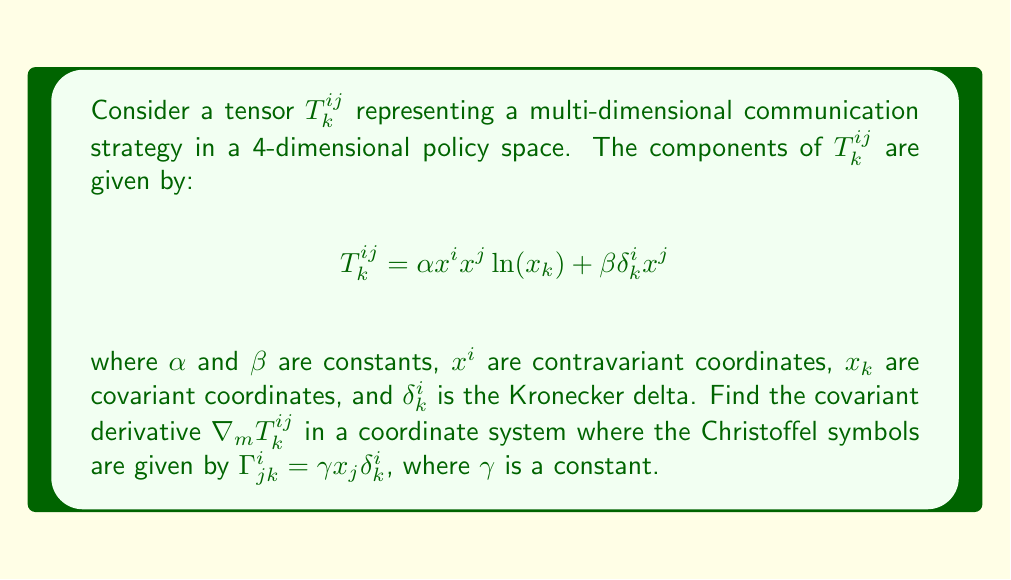Provide a solution to this math problem. To find the covariant derivative of the tensor $T^{ij}_k$, we use the formula:

$$\nabla_m T^{ij}_k = \partial_m T^{ij}_k + \Gamma^i_{mp}T^{pj}_k + \Gamma^j_{mp}T^{ip}_k - \Gamma^p_{mk}T^{ij}_p$$

Let's calculate each term:

1) $\partial_m T^{ij}_k$:
   $$\partial_m T^{ij}_k = \alpha (\delta^i_m x^j \ln(x_k) + x^i \delta^j_m \ln(x_k) + x^i x^j \frac{1}{x_k}\delta^k_m) + \beta \delta^i_k \delta^j_m$$

2) $\Gamma^i_{mp}T^{pj}_k$:
   $$\Gamma^i_{mp}T^{pj}_k = \gamma x_m \delta^i_p (\alpha x^p x^j \ln(x_k) + \beta \delta^p_k x^j) = \gamma x_m (\alpha x^i x^j \ln(x_k) + \beta \delta^i_k x^j)$$

3) $\Gamma^j_{mp}T^{ip}_k$:
   $$\Gamma^j_{mp}T^{ip}_k = \gamma x_m \delta^j_p (\alpha x^i x^p \ln(x_k) + \beta \delta^i_k x^p) = \gamma x_m (\alpha x^i x^j \ln(x_k) + \beta \delta^i_k x^j)$$

4) $\Gamma^p_{mk}T^{ij}_p$:
   $$\Gamma^p_{mk}T^{ij}_p = \gamma x_m \delta^p_k (\alpha x^i x^j \ln(x_p) + \beta \delta^i_p x^j) = \gamma x_m (\alpha x^i x^j \ln(x_k) + \beta \delta^i_k x^j)$$

Combining all terms:

$$\begin{align*}
\nabla_m T^{ij}_k &= \alpha (\delta^i_m x^j \ln(x_k) + x^i \delta^j_m \ln(x_k) + x^i x^j \frac{1}{x_k}\delta^k_m) + \beta \delta^i_k \delta^j_m \\
&+ \gamma x_m (\alpha x^i x^j \ln(x_k) + \beta \delta^i_k x^j) \\
&+ \gamma x_m (\alpha x^i x^j \ln(x_k) + \beta \delta^i_k x^j) \\
&- \gamma x_m (\alpha x^i x^j \ln(x_k) + \beta \delta^i_k x^j)
\end{align*}$$

Simplifying:

$$\nabla_m T^{ij}_k = \alpha (\delta^i_m x^j \ln(x_k) + x^i \delta^j_m \ln(x_k) + x^i x^j \frac{1}{x_k}\delta^k_m) + \beta \delta^i_k \delta^j_m + \gamma x_m (\alpha x^i x^j \ln(x_k) + \beta \delta^i_k x^j)$$

This is the final expression for the covariant derivative of the tensor $T^{ij}_k$.
Answer: $$\nabla_m T^{ij}_k = \alpha (\delta^i_m x^j \ln(x_k) + x^i \delta^j_m \ln(x_k) + x^i x^j \frac{1}{x_k}\delta^k_m) + \beta \delta^i_k \delta^j_m + \gamma x_m (\alpha x^i x^j \ln(x_k) + \beta \delta^i_k x^j)$$ 